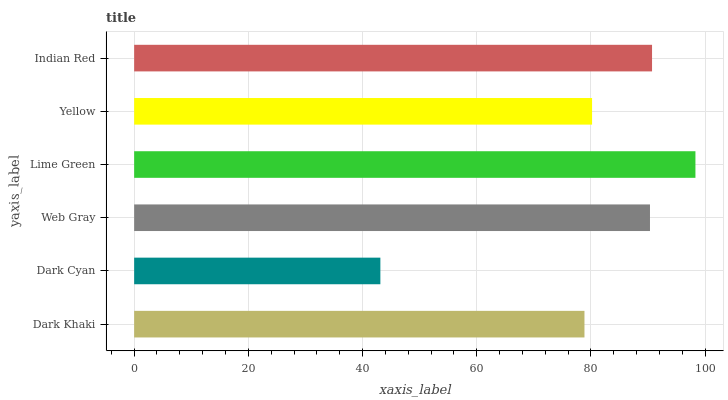Is Dark Cyan the minimum?
Answer yes or no. Yes. Is Lime Green the maximum?
Answer yes or no. Yes. Is Web Gray the minimum?
Answer yes or no. No. Is Web Gray the maximum?
Answer yes or no. No. Is Web Gray greater than Dark Cyan?
Answer yes or no. Yes. Is Dark Cyan less than Web Gray?
Answer yes or no. Yes. Is Dark Cyan greater than Web Gray?
Answer yes or no. No. Is Web Gray less than Dark Cyan?
Answer yes or no. No. Is Web Gray the high median?
Answer yes or no. Yes. Is Yellow the low median?
Answer yes or no. Yes. Is Lime Green the high median?
Answer yes or no. No. Is Dark Khaki the low median?
Answer yes or no. No. 